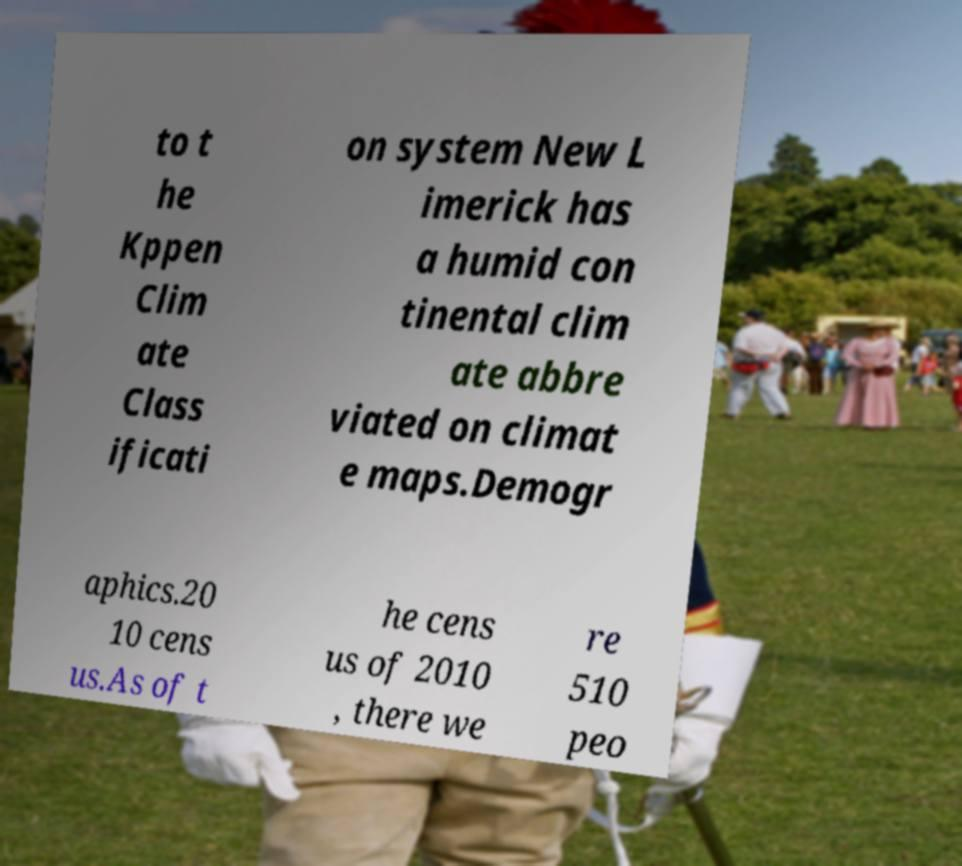What messages or text are displayed in this image? I need them in a readable, typed format. to t he Kppen Clim ate Class ificati on system New L imerick has a humid con tinental clim ate abbre viated on climat e maps.Demogr aphics.20 10 cens us.As of t he cens us of 2010 , there we re 510 peo 